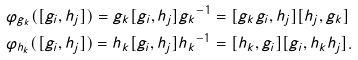Convert formula to latex. <formula><loc_0><loc_0><loc_500><loc_500>& \varphi _ { g _ { k } } ( [ g _ { i } , h _ { j } ] ) = { g _ { k } } [ g _ { i } , h _ { j } ] { g _ { k } } ^ { - 1 } = [ g _ { k } g _ { i } , h _ { j } ] [ h _ { j } , g _ { k } ] \\ & \varphi _ { h _ { k } } ( [ g _ { i } , h _ { j } ] ) = { h _ { k } } [ g _ { i } , h _ { j } ] { h _ { k } } ^ { - 1 } = [ h _ { k } , g _ { i } ] [ g _ { i } , h _ { k } h _ { j } ] .</formula> 